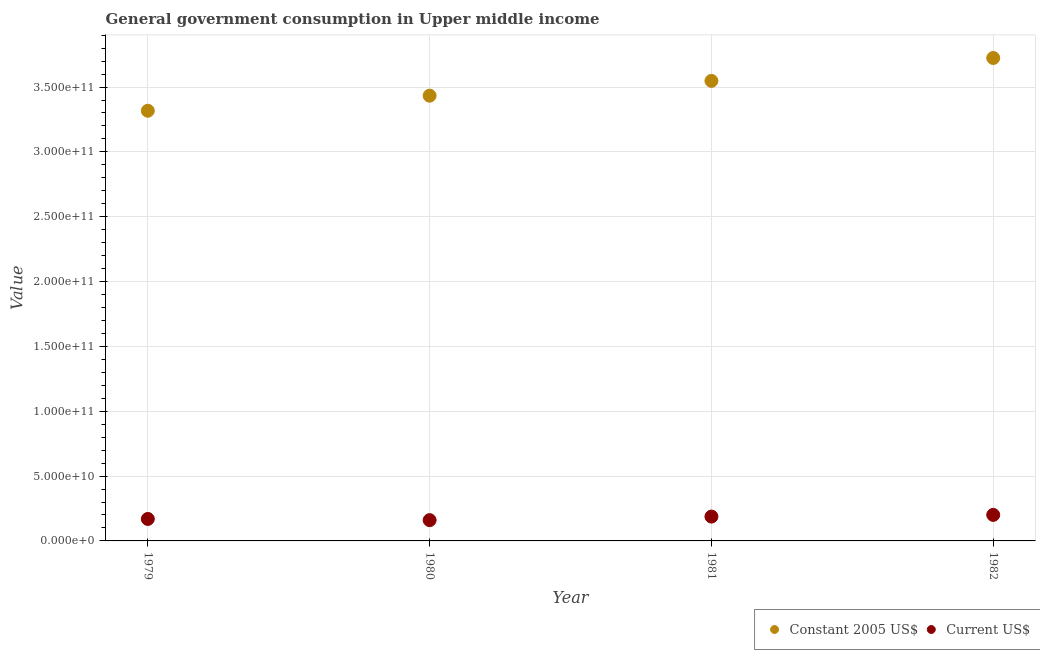How many different coloured dotlines are there?
Keep it short and to the point. 2. What is the value consumed in current us$ in 1982?
Your answer should be compact. 2.01e+1. Across all years, what is the maximum value consumed in current us$?
Give a very brief answer. 2.01e+1. Across all years, what is the minimum value consumed in constant 2005 us$?
Make the answer very short. 3.32e+11. What is the total value consumed in current us$ in the graph?
Your response must be concise. 7.18e+1. What is the difference between the value consumed in current us$ in 1980 and that in 1982?
Offer a terse response. -4.05e+09. What is the difference between the value consumed in constant 2005 us$ in 1981 and the value consumed in current us$ in 1980?
Your response must be concise. 3.39e+11. What is the average value consumed in constant 2005 us$ per year?
Give a very brief answer. 3.51e+11. In the year 1982, what is the difference between the value consumed in constant 2005 us$ and value consumed in current us$?
Provide a succinct answer. 3.52e+11. What is the ratio of the value consumed in current us$ in 1979 to that in 1980?
Ensure brevity in your answer.  1.06. Is the difference between the value consumed in constant 2005 us$ in 1980 and 1982 greater than the difference between the value consumed in current us$ in 1980 and 1982?
Provide a succinct answer. No. What is the difference between the highest and the second highest value consumed in constant 2005 us$?
Provide a short and direct response. 1.77e+1. What is the difference between the highest and the lowest value consumed in constant 2005 us$?
Your answer should be compact. 4.07e+1. In how many years, is the value consumed in constant 2005 us$ greater than the average value consumed in constant 2005 us$ taken over all years?
Offer a very short reply. 2. Is the sum of the value consumed in current us$ in 1979 and 1981 greater than the maximum value consumed in constant 2005 us$ across all years?
Ensure brevity in your answer.  No. Does the value consumed in constant 2005 us$ monotonically increase over the years?
Ensure brevity in your answer.  Yes. Is the value consumed in constant 2005 us$ strictly greater than the value consumed in current us$ over the years?
Give a very brief answer. Yes. Is the value consumed in constant 2005 us$ strictly less than the value consumed in current us$ over the years?
Provide a succinct answer. No. How many years are there in the graph?
Make the answer very short. 4. Are the values on the major ticks of Y-axis written in scientific E-notation?
Ensure brevity in your answer.  Yes. Does the graph contain any zero values?
Give a very brief answer. No. Where does the legend appear in the graph?
Offer a very short reply. Bottom right. How many legend labels are there?
Keep it short and to the point. 2. How are the legend labels stacked?
Keep it short and to the point. Horizontal. What is the title of the graph?
Keep it short and to the point. General government consumption in Upper middle income. What is the label or title of the X-axis?
Make the answer very short. Year. What is the label or title of the Y-axis?
Your answer should be compact. Value. What is the Value in Constant 2005 US$ in 1979?
Ensure brevity in your answer.  3.32e+11. What is the Value in Current US$ in 1979?
Keep it short and to the point. 1.69e+1. What is the Value of Constant 2005 US$ in 1980?
Provide a short and direct response. 3.43e+11. What is the Value in Current US$ in 1980?
Offer a terse response. 1.60e+1. What is the Value of Constant 2005 US$ in 1981?
Offer a terse response. 3.55e+11. What is the Value of Current US$ in 1981?
Give a very brief answer. 1.88e+1. What is the Value in Constant 2005 US$ in 1982?
Keep it short and to the point. 3.72e+11. What is the Value of Current US$ in 1982?
Ensure brevity in your answer.  2.01e+1. Across all years, what is the maximum Value in Constant 2005 US$?
Your response must be concise. 3.72e+11. Across all years, what is the maximum Value in Current US$?
Offer a terse response. 2.01e+1. Across all years, what is the minimum Value in Constant 2005 US$?
Offer a terse response. 3.32e+11. Across all years, what is the minimum Value in Current US$?
Your answer should be compact. 1.60e+1. What is the total Value of Constant 2005 US$ in the graph?
Your response must be concise. 1.40e+12. What is the total Value in Current US$ in the graph?
Ensure brevity in your answer.  7.18e+1. What is the difference between the Value in Constant 2005 US$ in 1979 and that in 1980?
Offer a terse response. -1.16e+1. What is the difference between the Value of Current US$ in 1979 and that in 1980?
Your response must be concise. 9.03e+08. What is the difference between the Value in Constant 2005 US$ in 1979 and that in 1981?
Your response must be concise. -2.30e+1. What is the difference between the Value of Current US$ in 1979 and that in 1981?
Ensure brevity in your answer.  -1.83e+09. What is the difference between the Value of Constant 2005 US$ in 1979 and that in 1982?
Your response must be concise. -4.07e+1. What is the difference between the Value in Current US$ in 1979 and that in 1982?
Offer a terse response. -3.14e+09. What is the difference between the Value in Constant 2005 US$ in 1980 and that in 1981?
Give a very brief answer. -1.14e+1. What is the difference between the Value in Current US$ in 1980 and that in 1981?
Keep it short and to the point. -2.74e+09. What is the difference between the Value of Constant 2005 US$ in 1980 and that in 1982?
Give a very brief answer. -2.91e+1. What is the difference between the Value of Current US$ in 1980 and that in 1982?
Offer a terse response. -4.05e+09. What is the difference between the Value in Constant 2005 US$ in 1981 and that in 1982?
Provide a succinct answer. -1.77e+1. What is the difference between the Value of Current US$ in 1981 and that in 1982?
Offer a terse response. -1.31e+09. What is the difference between the Value in Constant 2005 US$ in 1979 and the Value in Current US$ in 1980?
Offer a very short reply. 3.16e+11. What is the difference between the Value in Constant 2005 US$ in 1979 and the Value in Current US$ in 1981?
Provide a succinct answer. 3.13e+11. What is the difference between the Value of Constant 2005 US$ in 1979 and the Value of Current US$ in 1982?
Offer a very short reply. 3.12e+11. What is the difference between the Value of Constant 2005 US$ in 1980 and the Value of Current US$ in 1981?
Make the answer very short. 3.25e+11. What is the difference between the Value in Constant 2005 US$ in 1980 and the Value in Current US$ in 1982?
Your response must be concise. 3.23e+11. What is the difference between the Value in Constant 2005 US$ in 1981 and the Value in Current US$ in 1982?
Your response must be concise. 3.35e+11. What is the average Value in Constant 2005 US$ per year?
Give a very brief answer. 3.51e+11. What is the average Value of Current US$ per year?
Make the answer very short. 1.80e+1. In the year 1979, what is the difference between the Value of Constant 2005 US$ and Value of Current US$?
Keep it short and to the point. 3.15e+11. In the year 1980, what is the difference between the Value of Constant 2005 US$ and Value of Current US$?
Offer a very short reply. 3.27e+11. In the year 1981, what is the difference between the Value in Constant 2005 US$ and Value in Current US$?
Your response must be concise. 3.36e+11. In the year 1982, what is the difference between the Value of Constant 2005 US$ and Value of Current US$?
Offer a terse response. 3.52e+11. What is the ratio of the Value of Constant 2005 US$ in 1979 to that in 1980?
Your answer should be compact. 0.97. What is the ratio of the Value of Current US$ in 1979 to that in 1980?
Ensure brevity in your answer.  1.06. What is the ratio of the Value of Constant 2005 US$ in 1979 to that in 1981?
Your response must be concise. 0.94. What is the ratio of the Value of Current US$ in 1979 to that in 1981?
Give a very brief answer. 0.9. What is the ratio of the Value of Constant 2005 US$ in 1979 to that in 1982?
Make the answer very short. 0.89. What is the ratio of the Value in Current US$ in 1979 to that in 1982?
Your answer should be compact. 0.84. What is the ratio of the Value in Constant 2005 US$ in 1980 to that in 1981?
Offer a terse response. 0.97. What is the ratio of the Value of Current US$ in 1980 to that in 1981?
Ensure brevity in your answer.  0.85. What is the ratio of the Value in Constant 2005 US$ in 1980 to that in 1982?
Your answer should be very brief. 0.92. What is the ratio of the Value of Current US$ in 1980 to that in 1982?
Your answer should be compact. 0.8. What is the ratio of the Value in Constant 2005 US$ in 1981 to that in 1982?
Your answer should be very brief. 0.95. What is the ratio of the Value of Current US$ in 1981 to that in 1982?
Make the answer very short. 0.93. What is the difference between the highest and the second highest Value of Constant 2005 US$?
Your answer should be very brief. 1.77e+1. What is the difference between the highest and the second highest Value in Current US$?
Ensure brevity in your answer.  1.31e+09. What is the difference between the highest and the lowest Value in Constant 2005 US$?
Keep it short and to the point. 4.07e+1. What is the difference between the highest and the lowest Value of Current US$?
Your answer should be very brief. 4.05e+09. 